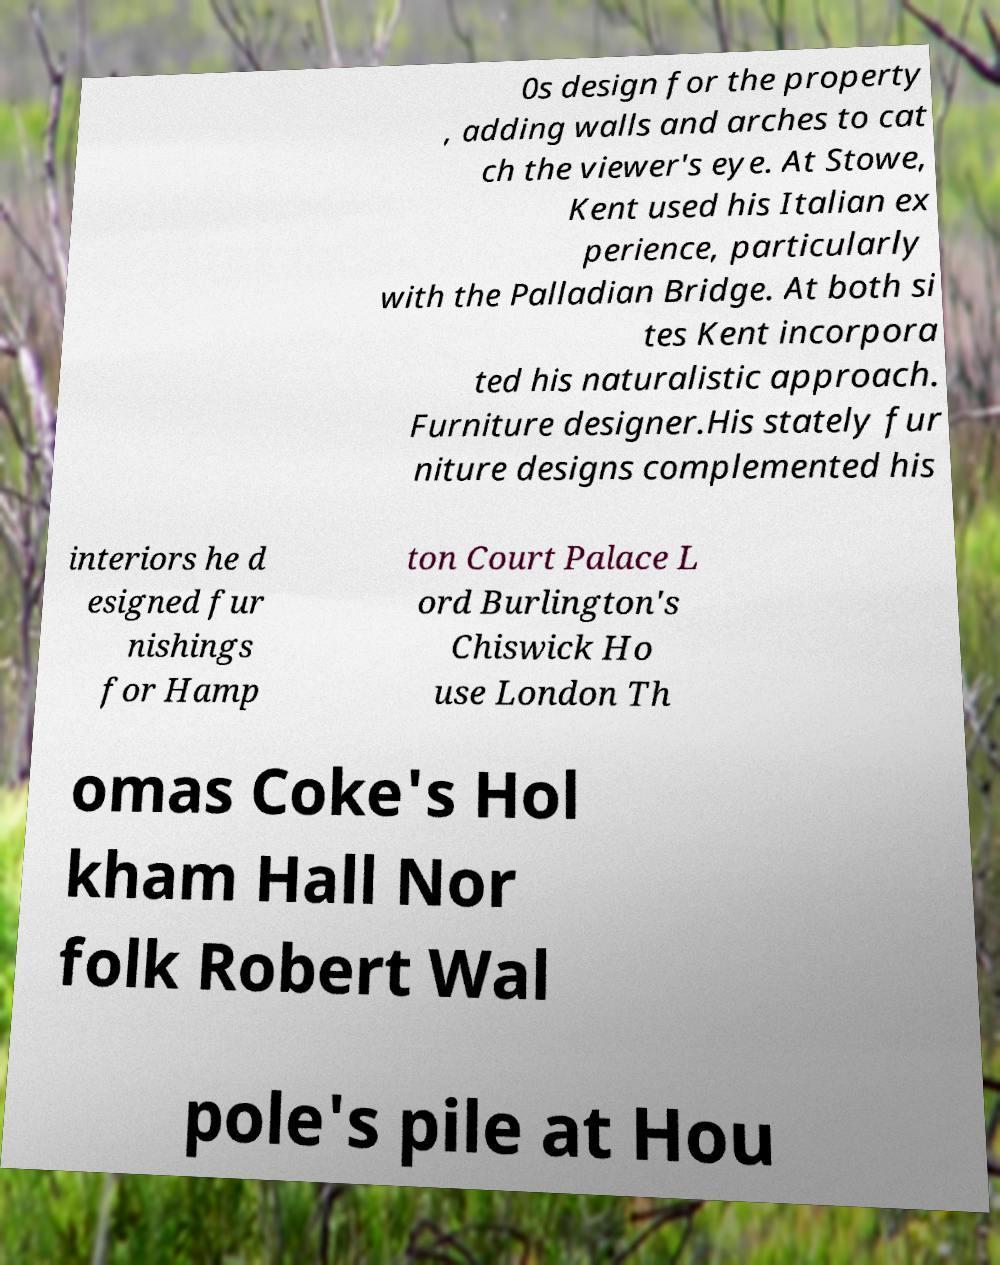Please identify and transcribe the text found in this image. 0s design for the property , adding walls and arches to cat ch the viewer's eye. At Stowe, Kent used his Italian ex perience, particularly with the Palladian Bridge. At both si tes Kent incorpora ted his naturalistic approach. Furniture designer.His stately fur niture designs complemented his interiors he d esigned fur nishings for Hamp ton Court Palace L ord Burlington's Chiswick Ho use London Th omas Coke's Hol kham Hall Nor folk Robert Wal pole's pile at Hou 